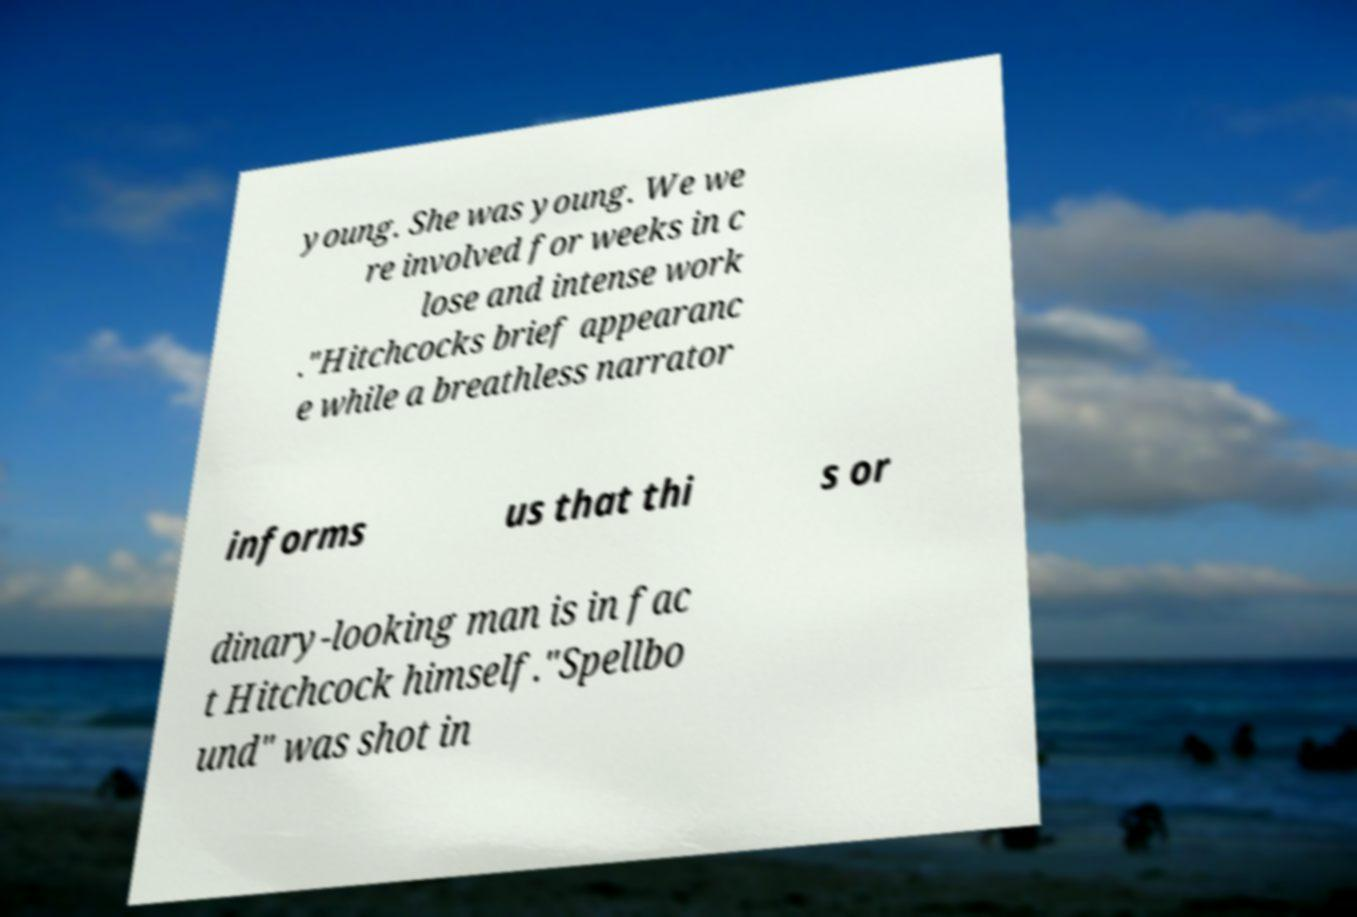There's text embedded in this image that I need extracted. Can you transcribe it verbatim? young. She was young. We we re involved for weeks in c lose and intense work ."Hitchcocks brief appearanc e while a breathless narrator informs us that thi s or dinary-looking man is in fac t Hitchcock himself."Spellbo und" was shot in 